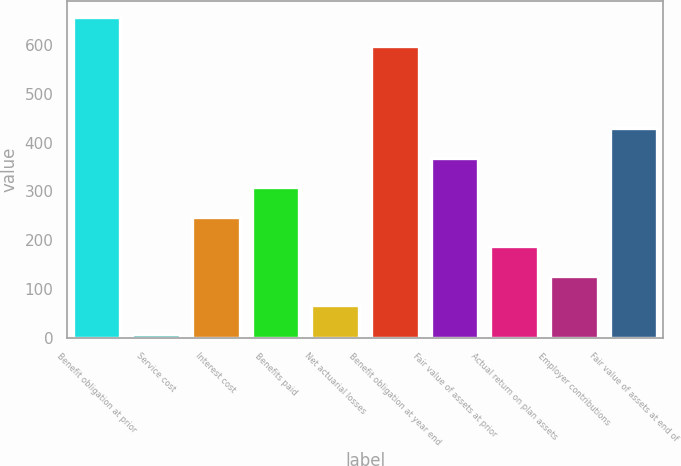Convert chart. <chart><loc_0><loc_0><loc_500><loc_500><bar_chart><fcel>Benefit obligation at prior<fcel>Service cost<fcel>Interest cost<fcel>Benefits paid<fcel>Net actuarial losses<fcel>Benefit obligation at year end<fcel>Fair value of assets at prior<fcel>Actual return on plan assets<fcel>Employer contributions<fcel>Fair value of assets at end of<nl><fcel>657.9<fcel>7.1<fcel>248.3<fcel>308.6<fcel>67.4<fcel>597.6<fcel>368.9<fcel>188<fcel>127.7<fcel>429.2<nl></chart> 